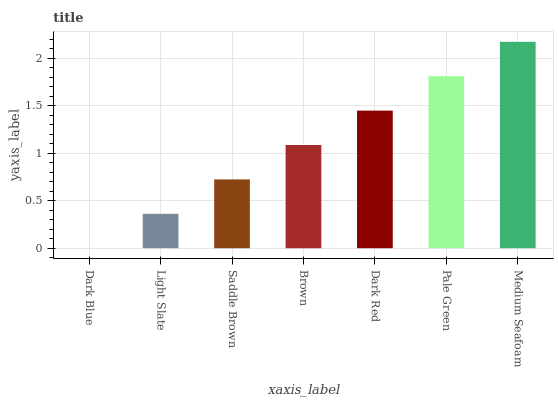Is Dark Blue the minimum?
Answer yes or no. Yes. Is Medium Seafoam the maximum?
Answer yes or no. Yes. Is Light Slate the minimum?
Answer yes or no. No. Is Light Slate the maximum?
Answer yes or no. No. Is Light Slate greater than Dark Blue?
Answer yes or no. Yes. Is Dark Blue less than Light Slate?
Answer yes or no. Yes. Is Dark Blue greater than Light Slate?
Answer yes or no. No. Is Light Slate less than Dark Blue?
Answer yes or no. No. Is Brown the high median?
Answer yes or no. Yes. Is Brown the low median?
Answer yes or no. Yes. Is Dark Blue the high median?
Answer yes or no. No. Is Light Slate the low median?
Answer yes or no. No. 